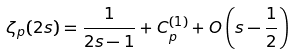<formula> <loc_0><loc_0><loc_500><loc_500>\zeta _ { p } ( 2 s ) = \frac { 1 } { 2 s - 1 } + C _ { p } ^ { ( 1 ) } + O \left ( s - \frac { 1 } { 2 } \right )</formula> 